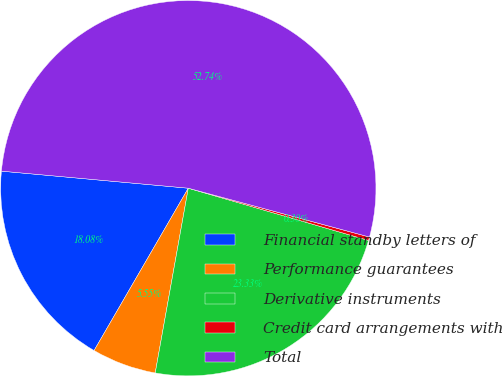Convert chart to OTSL. <chart><loc_0><loc_0><loc_500><loc_500><pie_chart><fcel>Financial standby letters of<fcel>Performance guarantees<fcel>Derivative instruments<fcel>Credit card arrangements with<fcel>Total<nl><fcel>18.08%<fcel>5.55%<fcel>23.33%<fcel>0.3%<fcel>52.74%<nl></chart> 